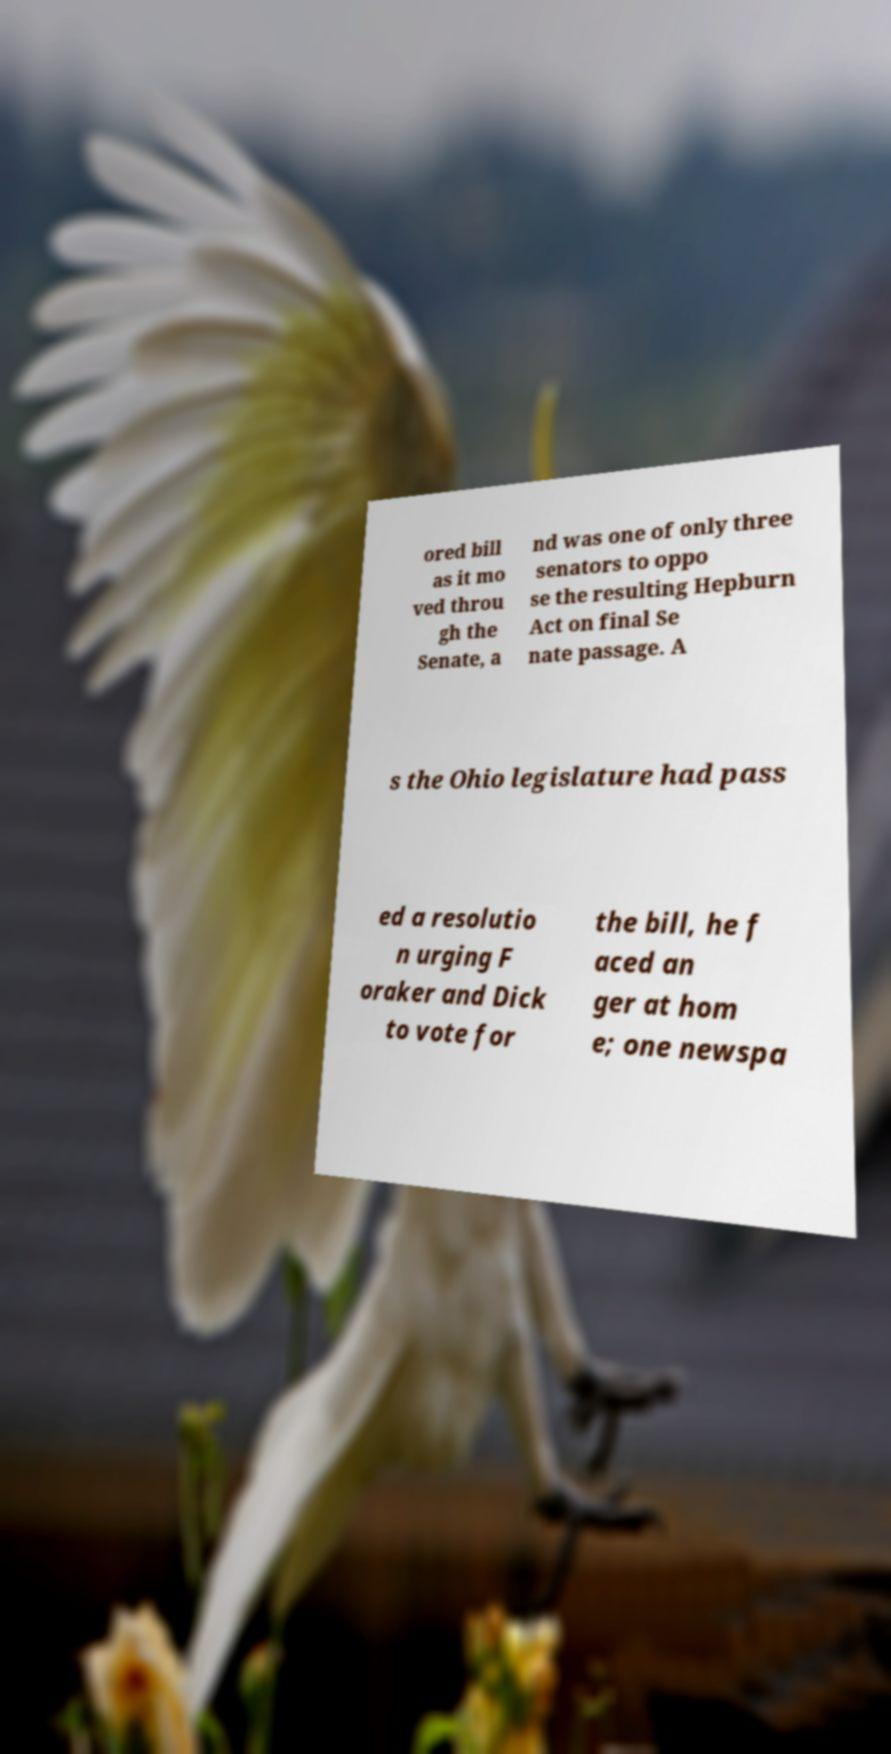Can you accurately transcribe the text from the provided image for me? ored bill as it mo ved throu gh the Senate, a nd was one of only three senators to oppo se the resulting Hepburn Act on final Se nate passage. A s the Ohio legislature had pass ed a resolutio n urging F oraker and Dick to vote for the bill, he f aced an ger at hom e; one newspa 